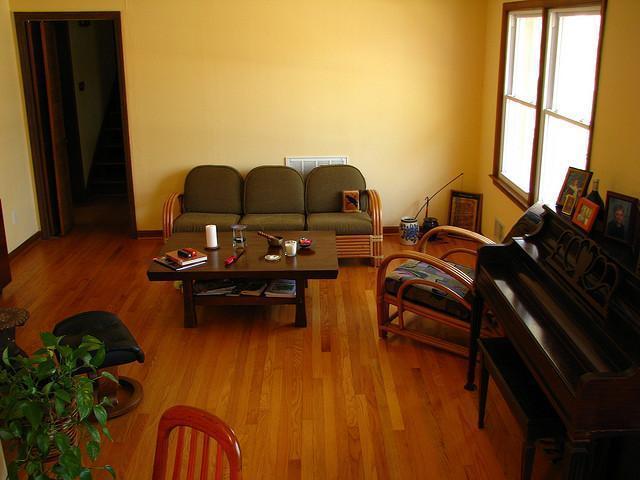How many chairs are in the photo?
Give a very brief answer. 3. 